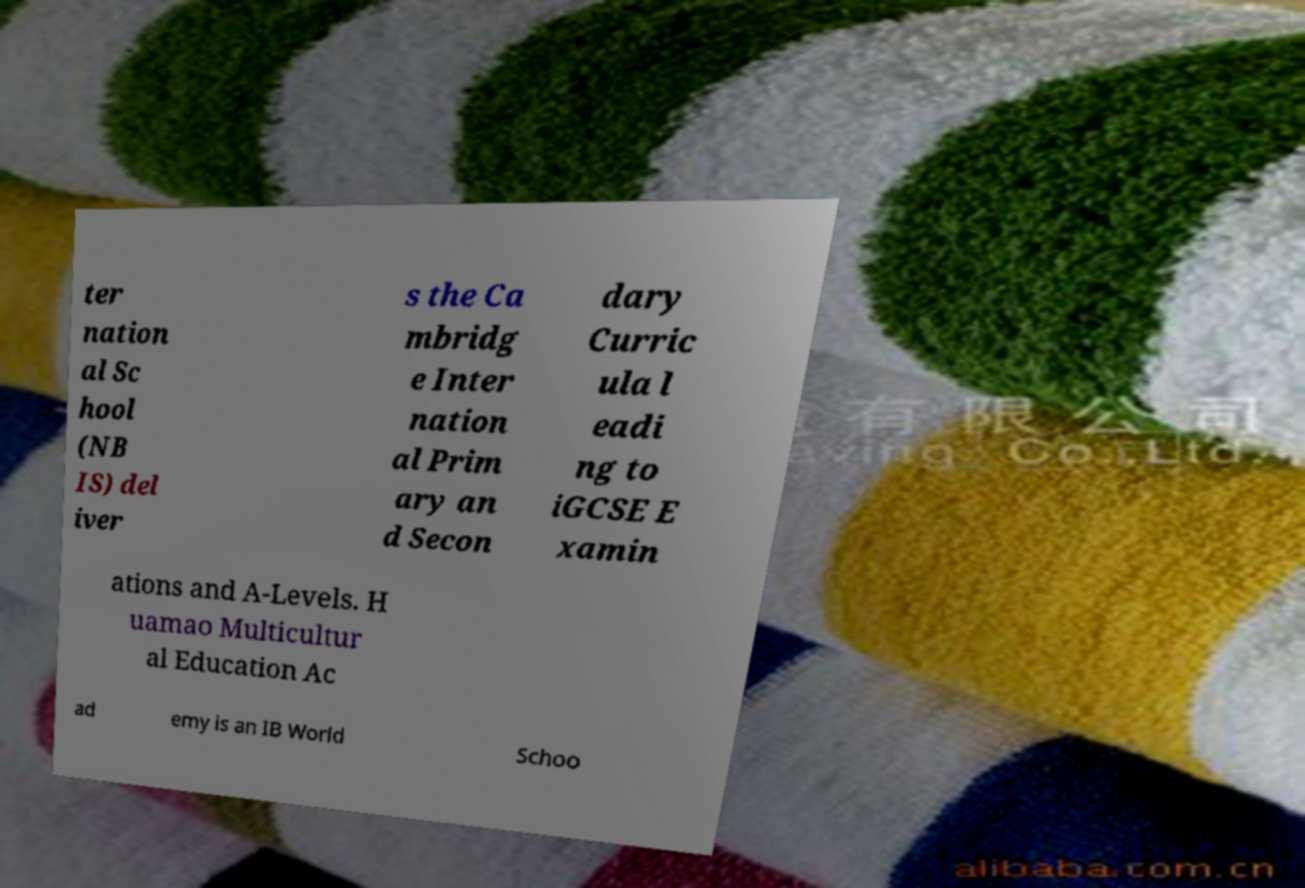Could you assist in decoding the text presented in this image and type it out clearly? ter nation al Sc hool (NB IS) del iver s the Ca mbridg e Inter nation al Prim ary an d Secon dary Curric ula l eadi ng to iGCSE E xamin ations and A-Levels. H uamao Multicultur al Education Ac ad emy is an IB World Schoo 